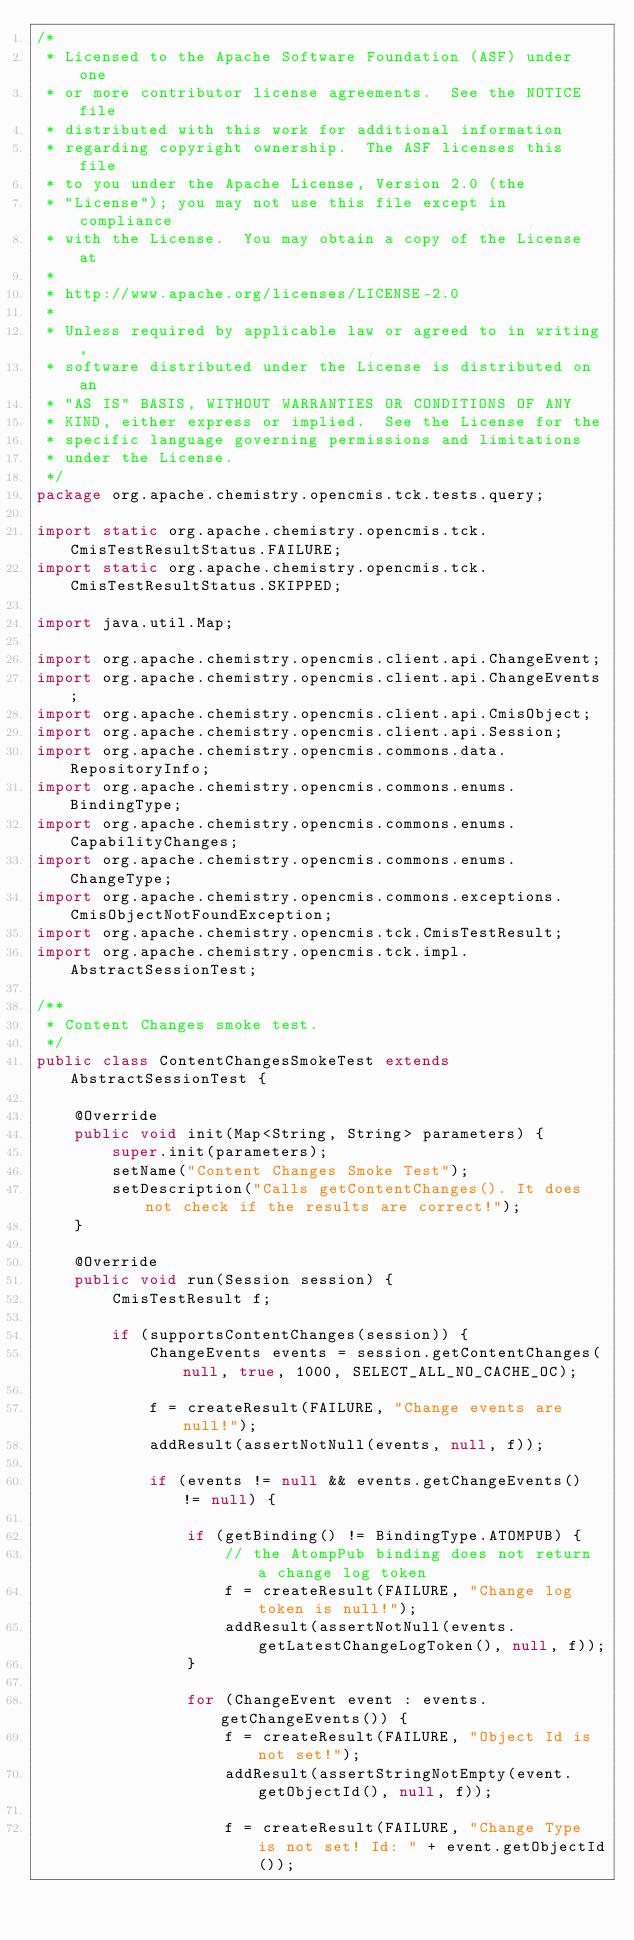<code> <loc_0><loc_0><loc_500><loc_500><_Java_>/*
 * Licensed to the Apache Software Foundation (ASF) under one
 * or more contributor license agreements.  See the NOTICE file
 * distributed with this work for additional information
 * regarding copyright ownership.  The ASF licenses this file
 * to you under the Apache License, Version 2.0 (the
 * "License"); you may not use this file except in compliance
 * with the License.  You may obtain a copy of the License at
 *
 * http://www.apache.org/licenses/LICENSE-2.0
 *
 * Unless required by applicable law or agreed to in writing,
 * software distributed under the License is distributed on an
 * "AS IS" BASIS, WITHOUT WARRANTIES OR CONDITIONS OF ANY
 * KIND, either express or implied.  See the License for the
 * specific language governing permissions and limitations
 * under the License.
 */
package org.apache.chemistry.opencmis.tck.tests.query;

import static org.apache.chemistry.opencmis.tck.CmisTestResultStatus.FAILURE;
import static org.apache.chemistry.opencmis.tck.CmisTestResultStatus.SKIPPED;

import java.util.Map;

import org.apache.chemistry.opencmis.client.api.ChangeEvent;
import org.apache.chemistry.opencmis.client.api.ChangeEvents;
import org.apache.chemistry.opencmis.client.api.CmisObject;
import org.apache.chemistry.opencmis.client.api.Session;
import org.apache.chemistry.opencmis.commons.data.RepositoryInfo;
import org.apache.chemistry.opencmis.commons.enums.BindingType;
import org.apache.chemistry.opencmis.commons.enums.CapabilityChanges;
import org.apache.chemistry.opencmis.commons.enums.ChangeType;
import org.apache.chemistry.opencmis.commons.exceptions.CmisObjectNotFoundException;
import org.apache.chemistry.opencmis.tck.CmisTestResult;
import org.apache.chemistry.opencmis.tck.impl.AbstractSessionTest;

/**
 * Content Changes smoke test.
 */
public class ContentChangesSmokeTest extends AbstractSessionTest {

    @Override
    public void init(Map<String, String> parameters) {
        super.init(parameters);
        setName("Content Changes Smoke Test");
        setDescription("Calls getContentChanges(). It does not check if the results are correct!");
    }

    @Override
    public void run(Session session) {
        CmisTestResult f;

        if (supportsContentChanges(session)) {
            ChangeEvents events = session.getContentChanges(null, true, 1000, SELECT_ALL_NO_CACHE_OC);

            f = createResult(FAILURE, "Change events are null!");
            addResult(assertNotNull(events, null, f));

            if (events != null && events.getChangeEvents() != null) {

                if (getBinding() != BindingType.ATOMPUB) {
                    // the AtompPub binding does not return a change log token
                    f = createResult(FAILURE, "Change log token is null!");
                    addResult(assertNotNull(events.getLatestChangeLogToken(), null, f));
                }

                for (ChangeEvent event : events.getChangeEvents()) {
                    f = createResult(FAILURE, "Object Id is not set!");
                    addResult(assertStringNotEmpty(event.getObjectId(), null, f));

                    f = createResult(FAILURE, "Change Type is not set! Id: " + event.getObjectId());</code> 